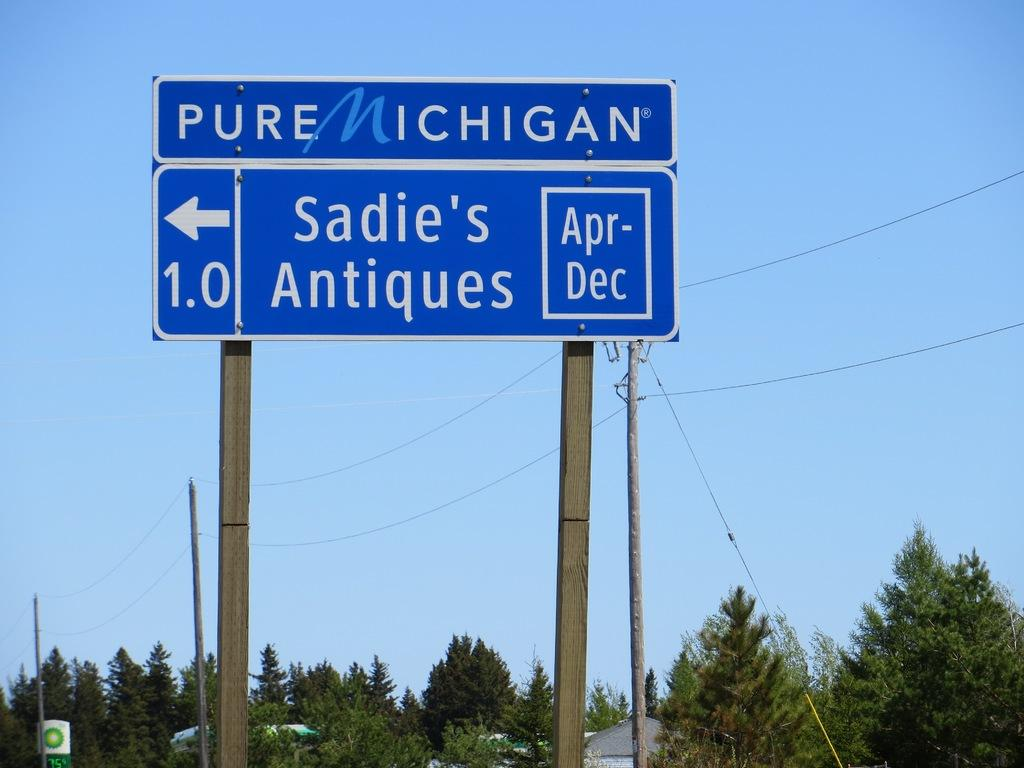Provide a one-sentence caption for the provided image. A Michigan road sign points the way to Sadie's Antiques. 